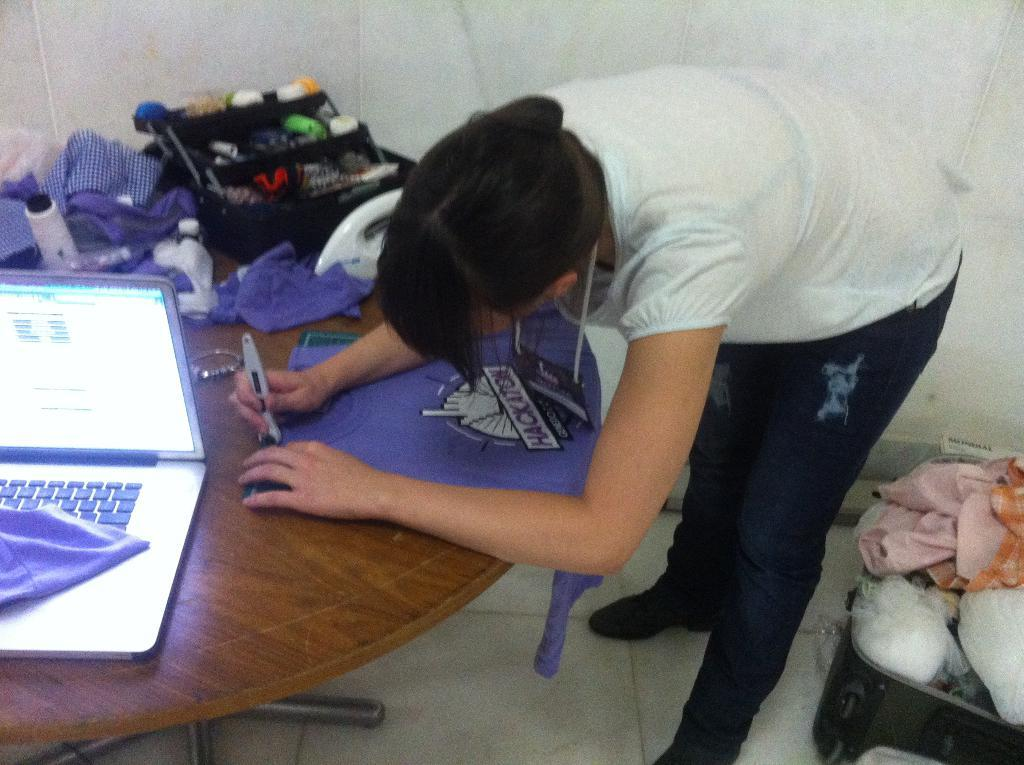Who is present in the image? There is a woman in the image. What is the woman doing in the image? The woman is standing at a table. What can be seen behind the woman? There is luggage behind her. What object is on the table in the image? There is a laptop on the table. What type of love is the woman expressing in the image? There is no indication of love or any emotional expression in the image; it simply shows a woman standing at a table with luggage behind her and a laptop on the table. 